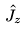Convert formula to latex. <formula><loc_0><loc_0><loc_500><loc_500>\hat { J _ { z } }</formula> 